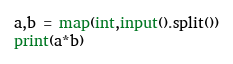<code> <loc_0><loc_0><loc_500><loc_500><_Python_>a,b = map(int,input().split())
print(a*b)</code> 